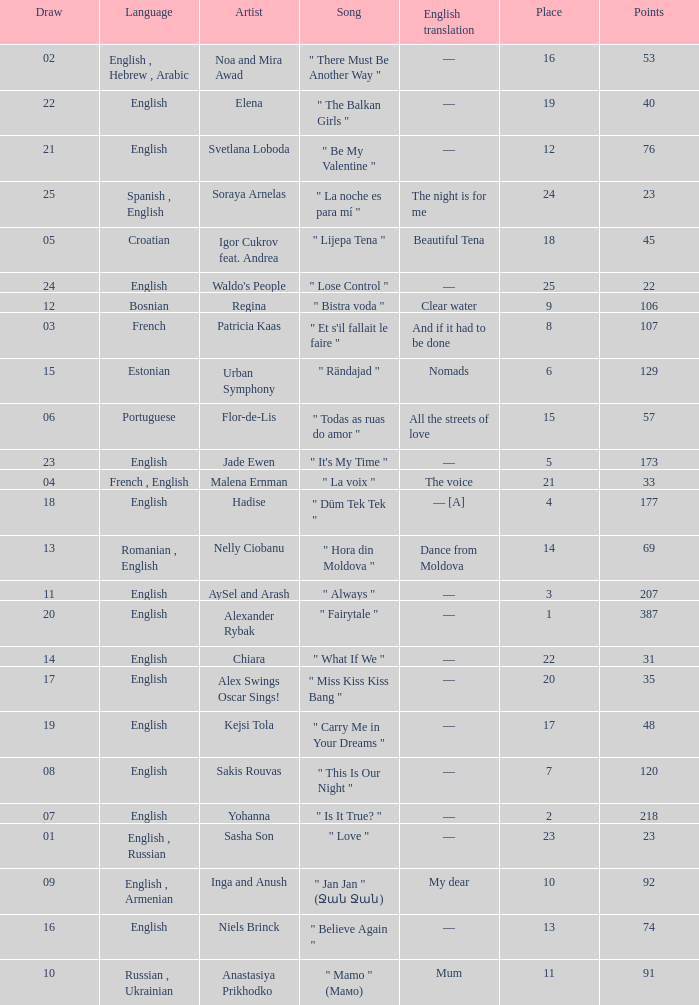What was the average place for the song that had 69 points and a draw smaller than 13? None. 